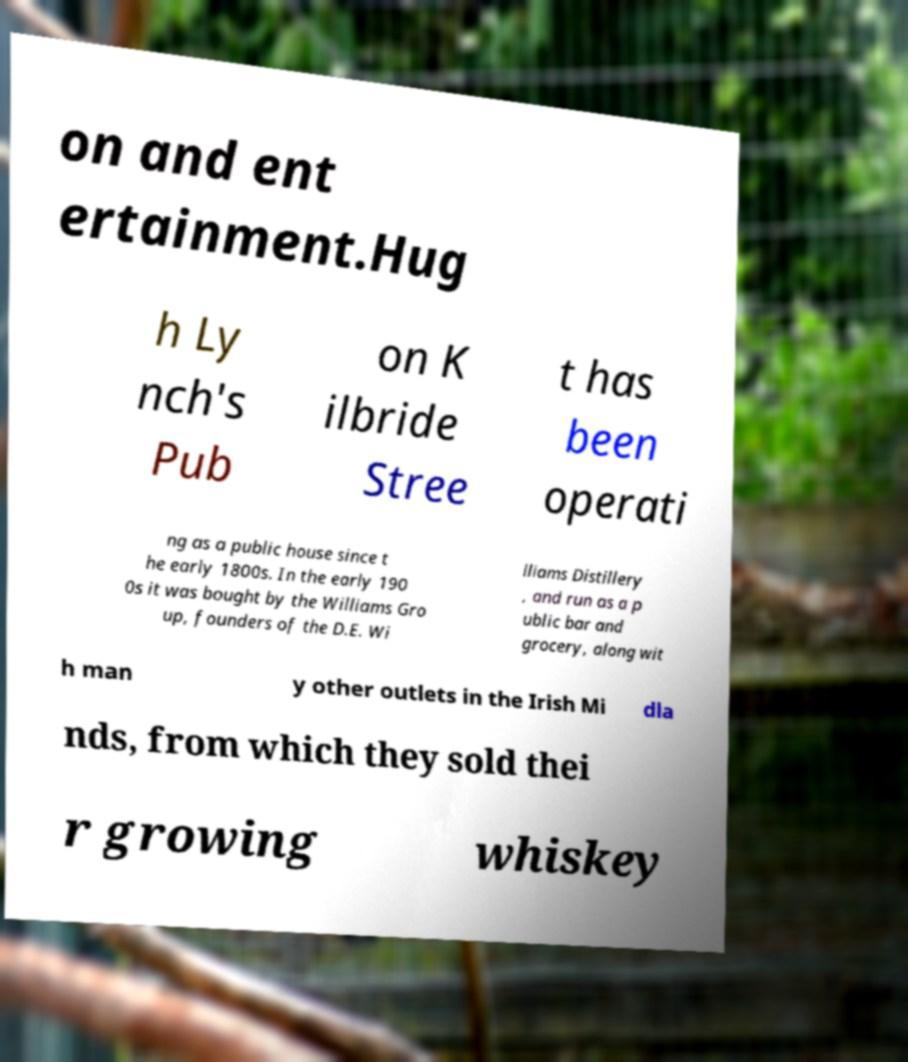I need the written content from this picture converted into text. Can you do that? on and ent ertainment.Hug h Ly nch's Pub on K ilbride Stree t has been operati ng as a public house since t he early 1800s. In the early 190 0s it was bought by the Williams Gro up, founders of the D.E. Wi lliams Distillery , and run as a p ublic bar and grocery, along wit h man y other outlets in the Irish Mi dla nds, from which they sold thei r growing whiskey 